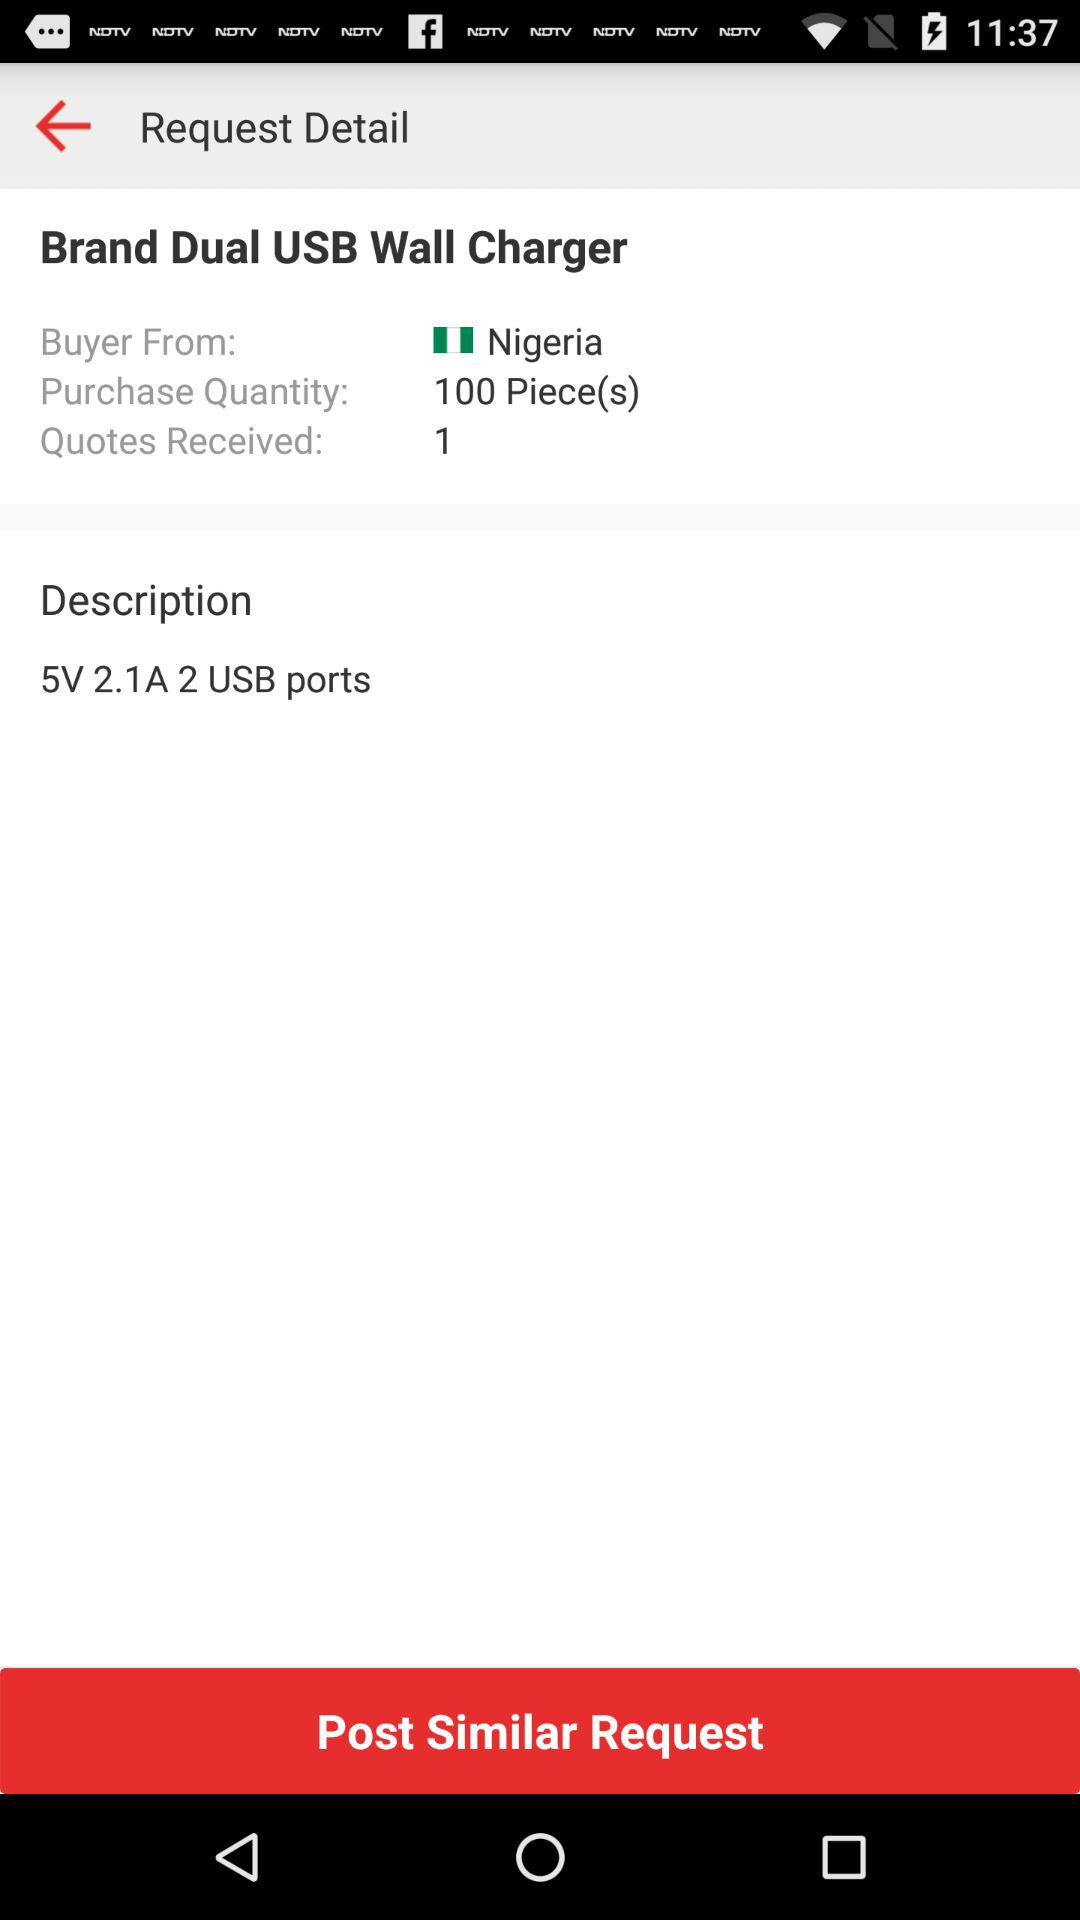What is the number of received quotes? The number of received quotes is 1. 